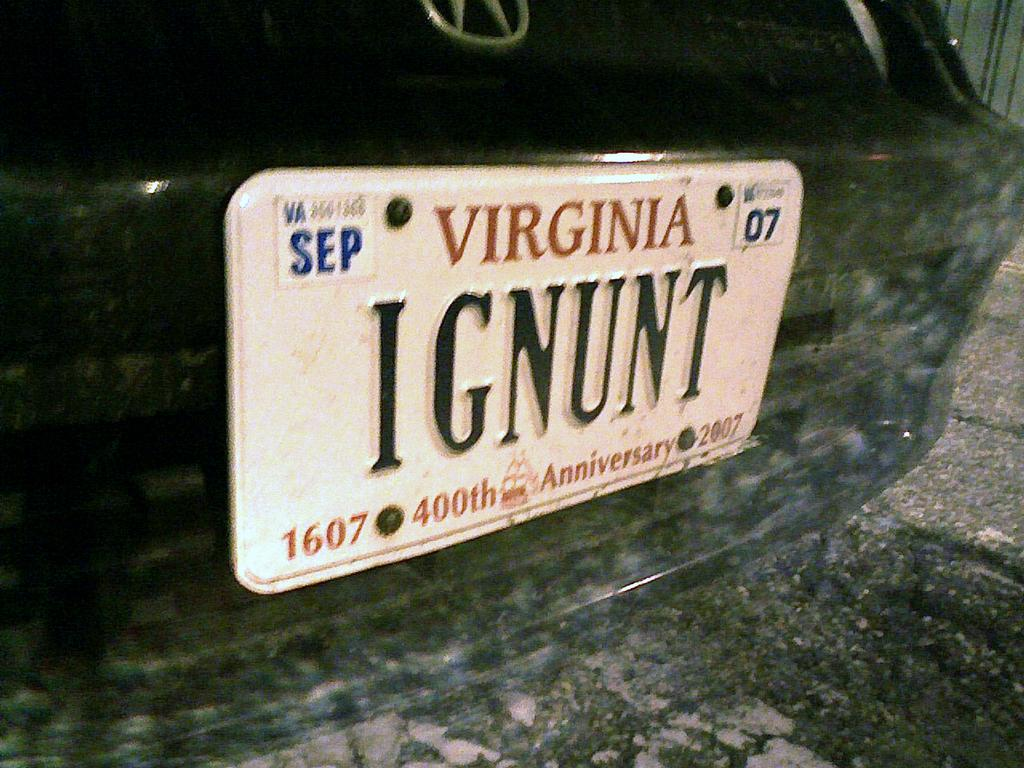<image>
Share a concise interpretation of the image provided. A Virginia license plate with IGNUNT on it. 